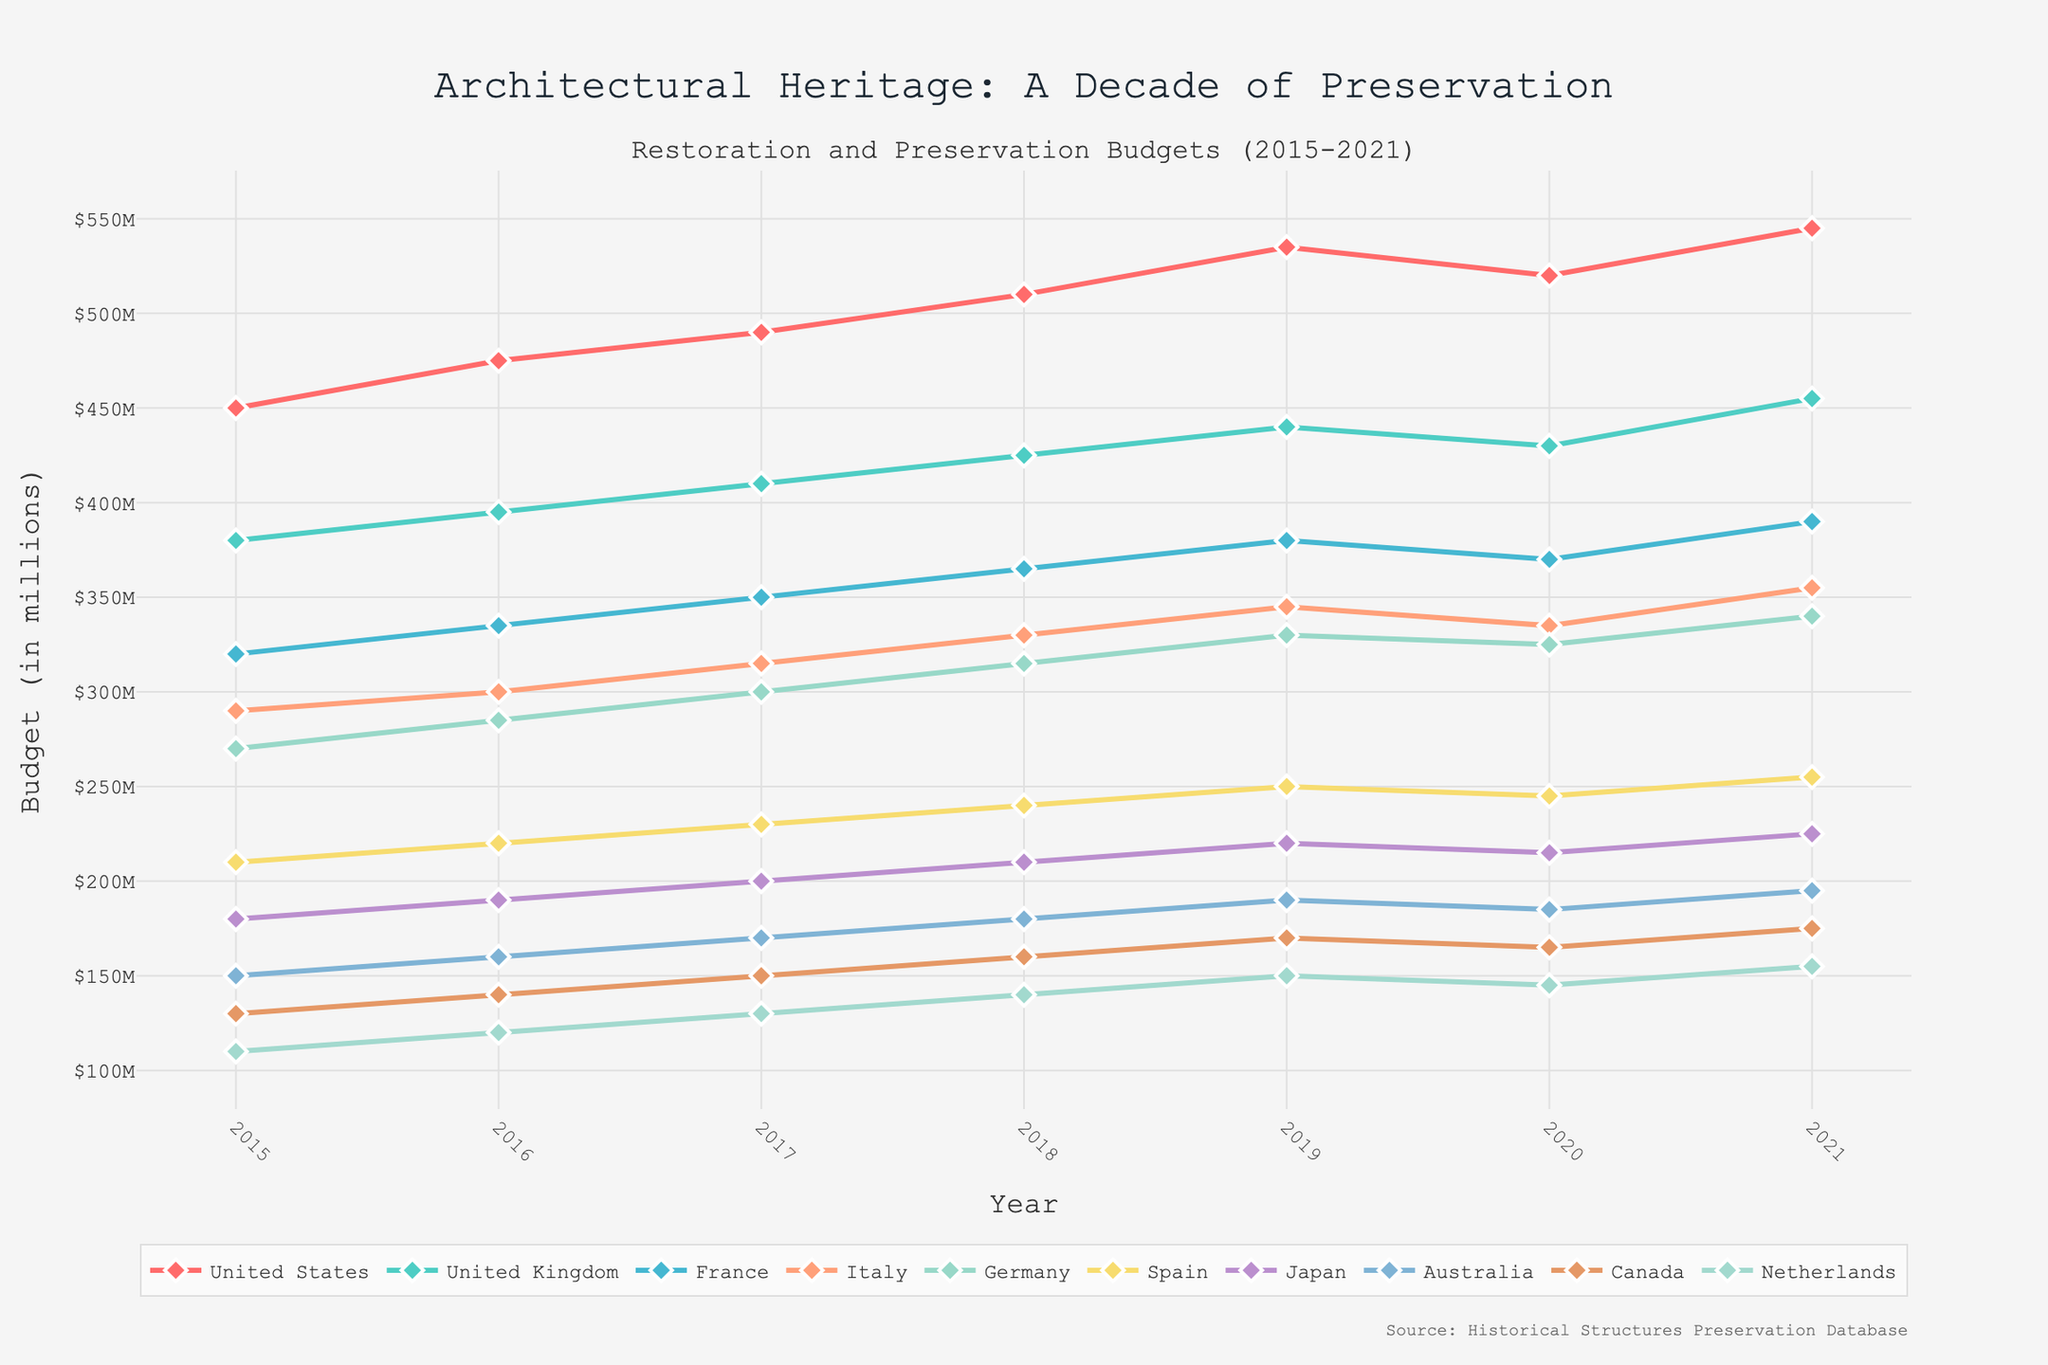Which country had the highest restoration and preservation budget in 2021? The chart shows each country's budget in 2021, with the United States having the highest value around $545 million.
Answer: United States What was the overall trend for Japan's budget from 2015 to 2021? By observing Japan's line, the budget consistently increased each year from 2015 ($180 million) to 2021 ($225 million).
Answer: Increasing How many countries had a higher budget in 2021 compared to 2020? Comparing 2021 and 2020 values for each country, budgets for United States, United Kingdom, France, Italy, Germany, Spain, Japan, Australia, Canada, and Netherlands increased.
Answer: 10 Compare the budget changes between the United States and the United Kingdom from 2015 to 2021. Which country had a more significant increase? The United States increased from $450 million to $545 million (an increase of $95 million) while the United Kingdom increased from $380 million to $455 million (an increase of $75 million). The United States had a more significant increase.
Answer: United States What is the average budget for Italy across the years shown? Adding Italy's budget values for 2015 to 2021 (290+300+315+330+345+335+355) and dividing by 7 gives the average budget as ((290+300+315+330+345+335+355) / 7) ≈ $324 million.
Answer: $324 million Which country had the least budget allocation in 2015? The chart indicates that the Netherlands had the smallest budget in 2015, being approximately $110 million.
Answer: Netherlands What was the maximum budget change for any country between consecutive years? The United States had the highest increase between 2018 and 2019, where it went from $510 million to $535 million, an increase of $25 million.
Answer: $25 million How did Germany's budget in 2020 compare to its budget in 2021? The chart shows Germany's budget slightly increased from $325 million in 2020 to $340 million in 2021.
Answer: Increased Identify the year with the most considerable collective increase in budget across all countries. Summing the year-to-year differences for each country, the year 2016 had an extensive collective increase with several countries showing significant increments from 2015 to 2016.
Answer: 2016 What is the total budget for Canada from 2015 to 2021? Summing Canada's budget values for each year (130+140+150+160+170+165+175) results in a total budget of 1090 million dollars.
Answer: $1090 million 